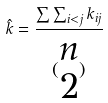<formula> <loc_0><loc_0><loc_500><loc_500>\hat { k } = \frac { \sum \sum _ { i < j } k _ { i j } } { ( \begin{matrix} n \\ 2 \end{matrix} ) }</formula> 